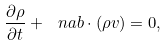<formula> <loc_0><loc_0><loc_500><loc_500>\frac { \partial \rho } { \partial t } + \ n a b \cdot \left ( \rho { v } \right ) = 0 ,</formula> 